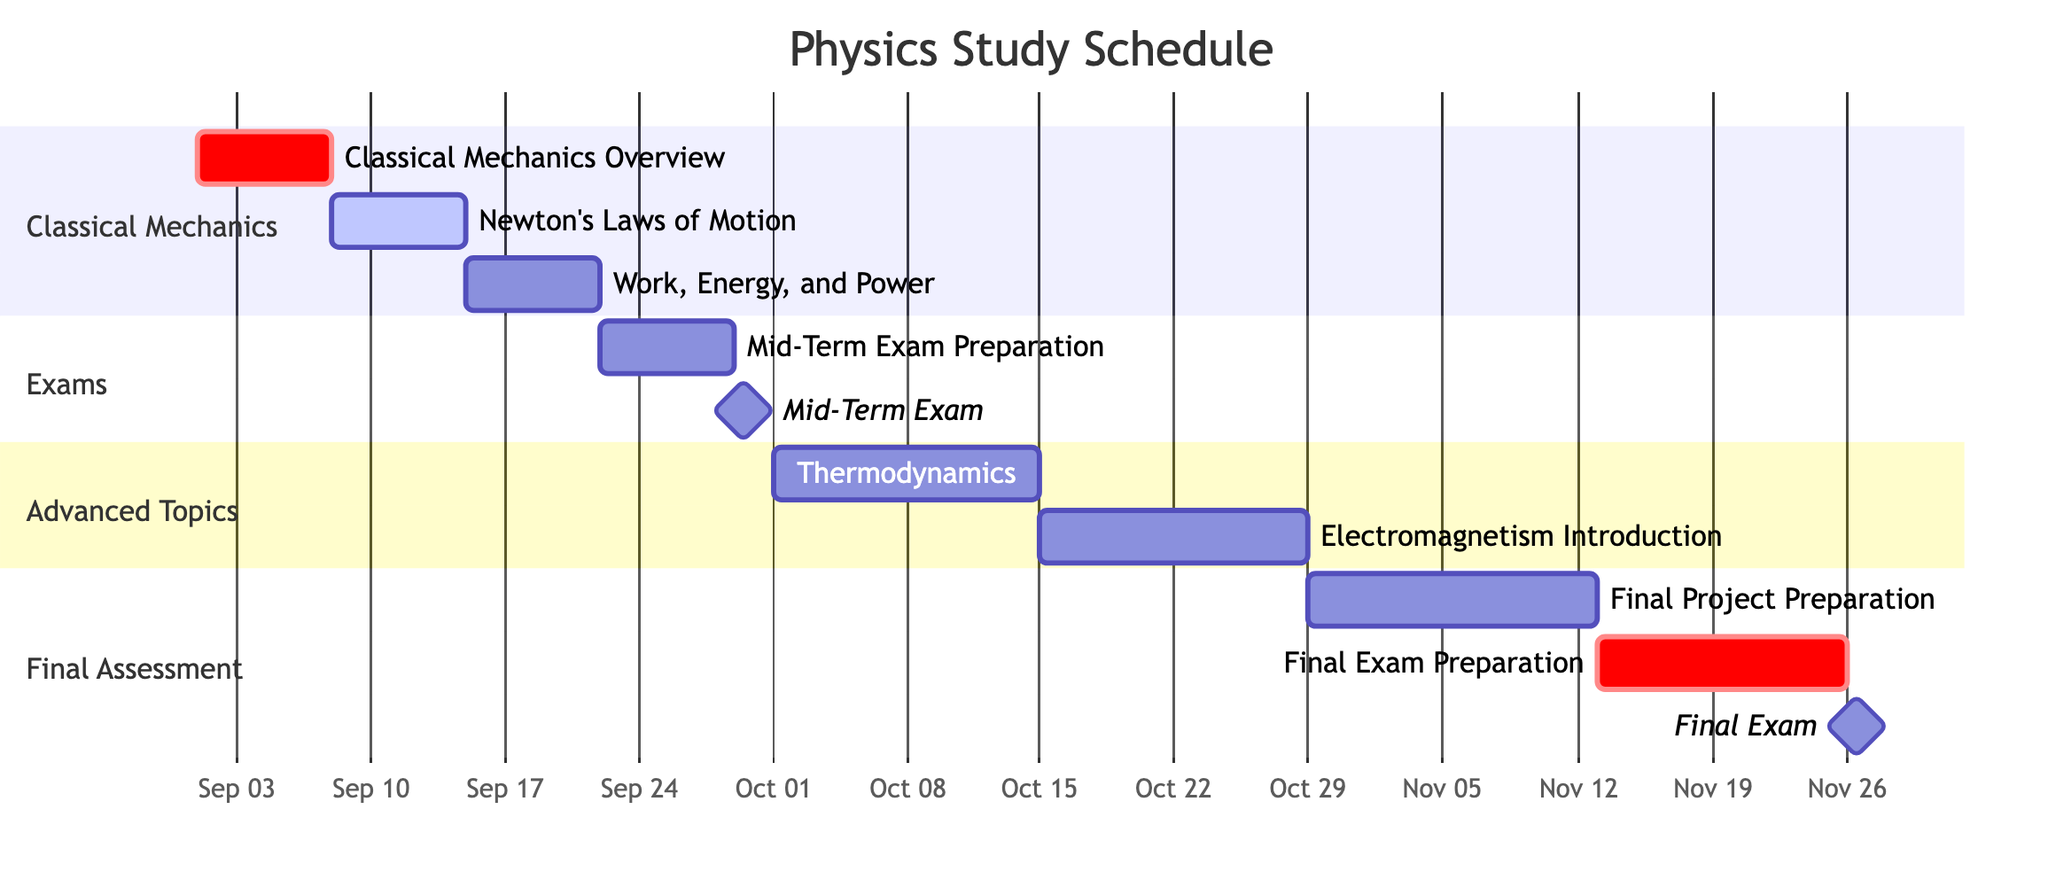What is the duration of the "Work, Energy, and Power" task? The task "Work, Energy, and Power" starts on September 15, 2023, and ends on September 21, 2023. Calculating the duration gives us 7 days.
Answer: 7 days How many tasks are dependent on the "Mid-Term Exam"? The "Mid-Term Exam" does not have any tasks listed as dependent on it in the diagram. Hence, the count of dependent tasks is zero.
Answer: 0 Which task follows immediately after "Newton's Laws of Motion"? The task that follows "Newton's Laws of Motion" is "Work, Energy, and Power," which is scheduled to start right after the completion of "Newton's Laws of Motion."
Answer: Work, Energy, and Power What is the end date of the "Electromagnetism Introduction" topic? The "Electromagnetism Introduction" task is scheduled to end on October 28, 2023, as indicated in its time frame.
Answer: October 28, 2023 Which task has the same start date as the "Final Exam"? The "Final Exam" starts on November 26, 2023, and the only task that has the same start date is the "Final Exam" itself since it is a milestone event.
Answer: Final Exam How many total days does the evaluation phase (both exams and preparations) cover? The evaluation phase includes "Mid-Term Exam Preparation" (7 days), "Mid-Term Exam" (1 day), "Final Project Preparation" (15 days), "Final Exam Preparation" (13 days), and "Final Exam" (1 day). Adding these gives 7 + 1 + 15 + 13 + 1 = 37 days.
Answer: 37 days What is the total number of tasks in the Gantt chart? Inspecting the diagram reveals a total of 10 tasks listed in the schedule, including all key topics and exam preparations.
Answer: 10 What section does "Thermodynamics" fall under? In the Gantt chart, "Thermodynamics" is categorized under the "Advanced Topics" section.
Answer: Advanced Topics Which task immediately precedes the "Final Exam"? The task that immediately precedes the "Final Exam" is "Final Exam Preparation," which is necessary for the completion before taking the final exam.
Answer: Final Exam Preparation 